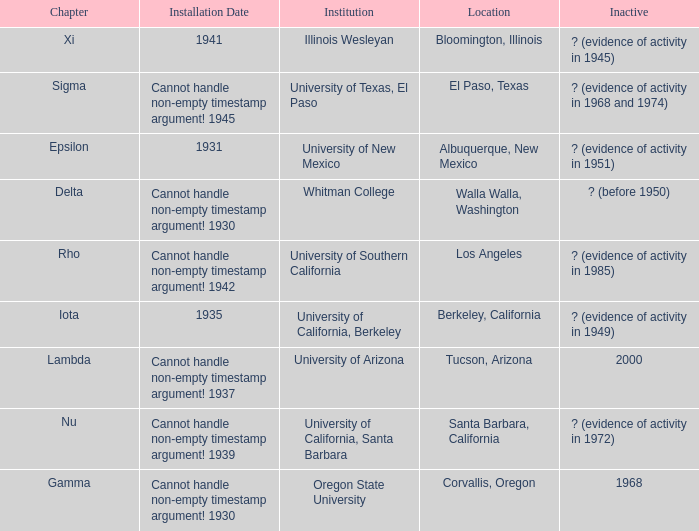What does the inactive state for University of Texas, El Paso?  ? (evidence of activity in 1968 and 1974). 